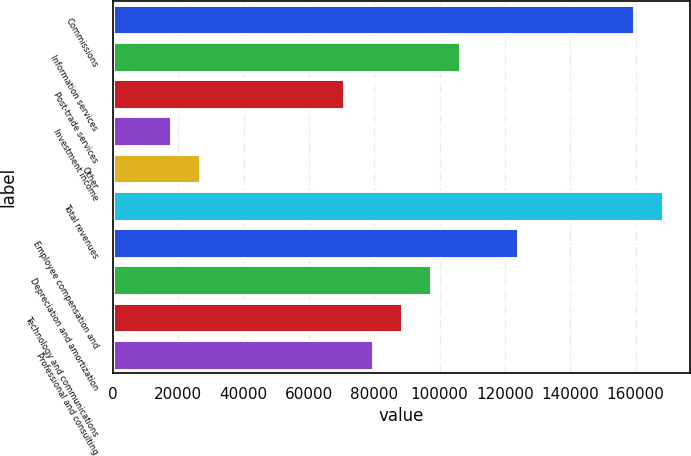Convert chart to OTSL. <chart><loc_0><loc_0><loc_500><loc_500><bar_chart><fcel>Commissions<fcel>Information services<fcel>Post-trade services<fcel>Investment income<fcel>Other<fcel>Total revenues<fcel>Employee compensation and<fcel>Depreciation and amortization<fcel>Technology and communications<fcel>Professional and consulting<nl><fcel>159431<fcel>106287<fcel>70858.5<fcel>17715.2<fcel>26572.4<fcel>168288<fcel>124002<fcel>97430.2<fcel>88573<fcel>79715.8<nl></chart> 